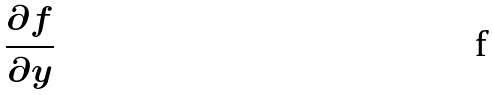Convert formula to latex. <formula><loc_0><loc_0><loc_500><loc_500>\frac { \partial f } { \partial y }</formula> 